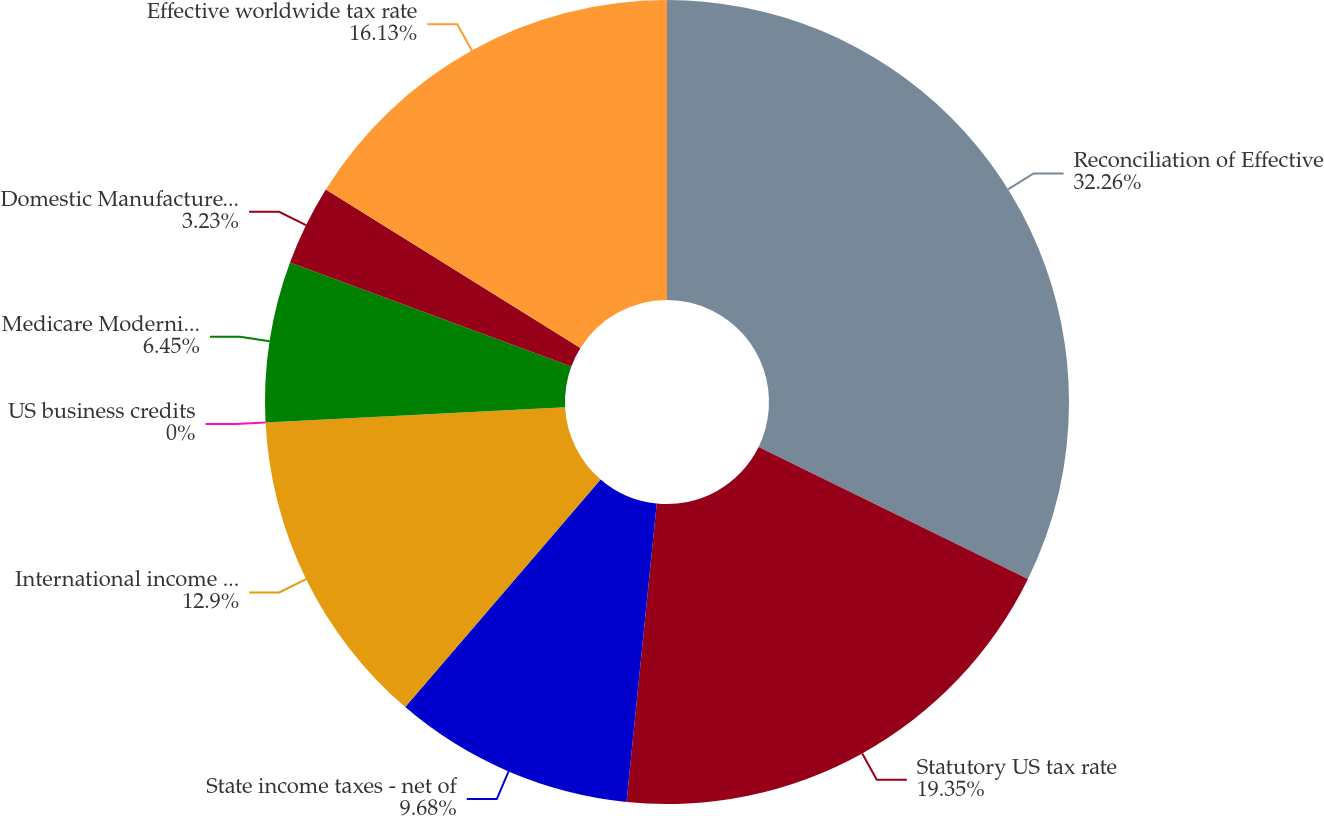Convert chart to OTSL. <chart><loc_0><loc_0><loc_500><loc_500><pie_chart><fcel>Reconciliation of Effective<fcel>Statutory US tax rate<fcel>State income taxes - net of<fcel>International income taxes -<fcel>US business credits<fcel>Medicare Modernization Act<fcel>Domestic Manufacturer's<fcel>Effective worldwide tax rate<nl><fcel>32.25%<fcel>19.35%<fcel>9.68%<fcel>12.9%<fcel>0.0%<fcel>6.45%<fcel>3.23%<fcel>16.13%<nl></chart> 